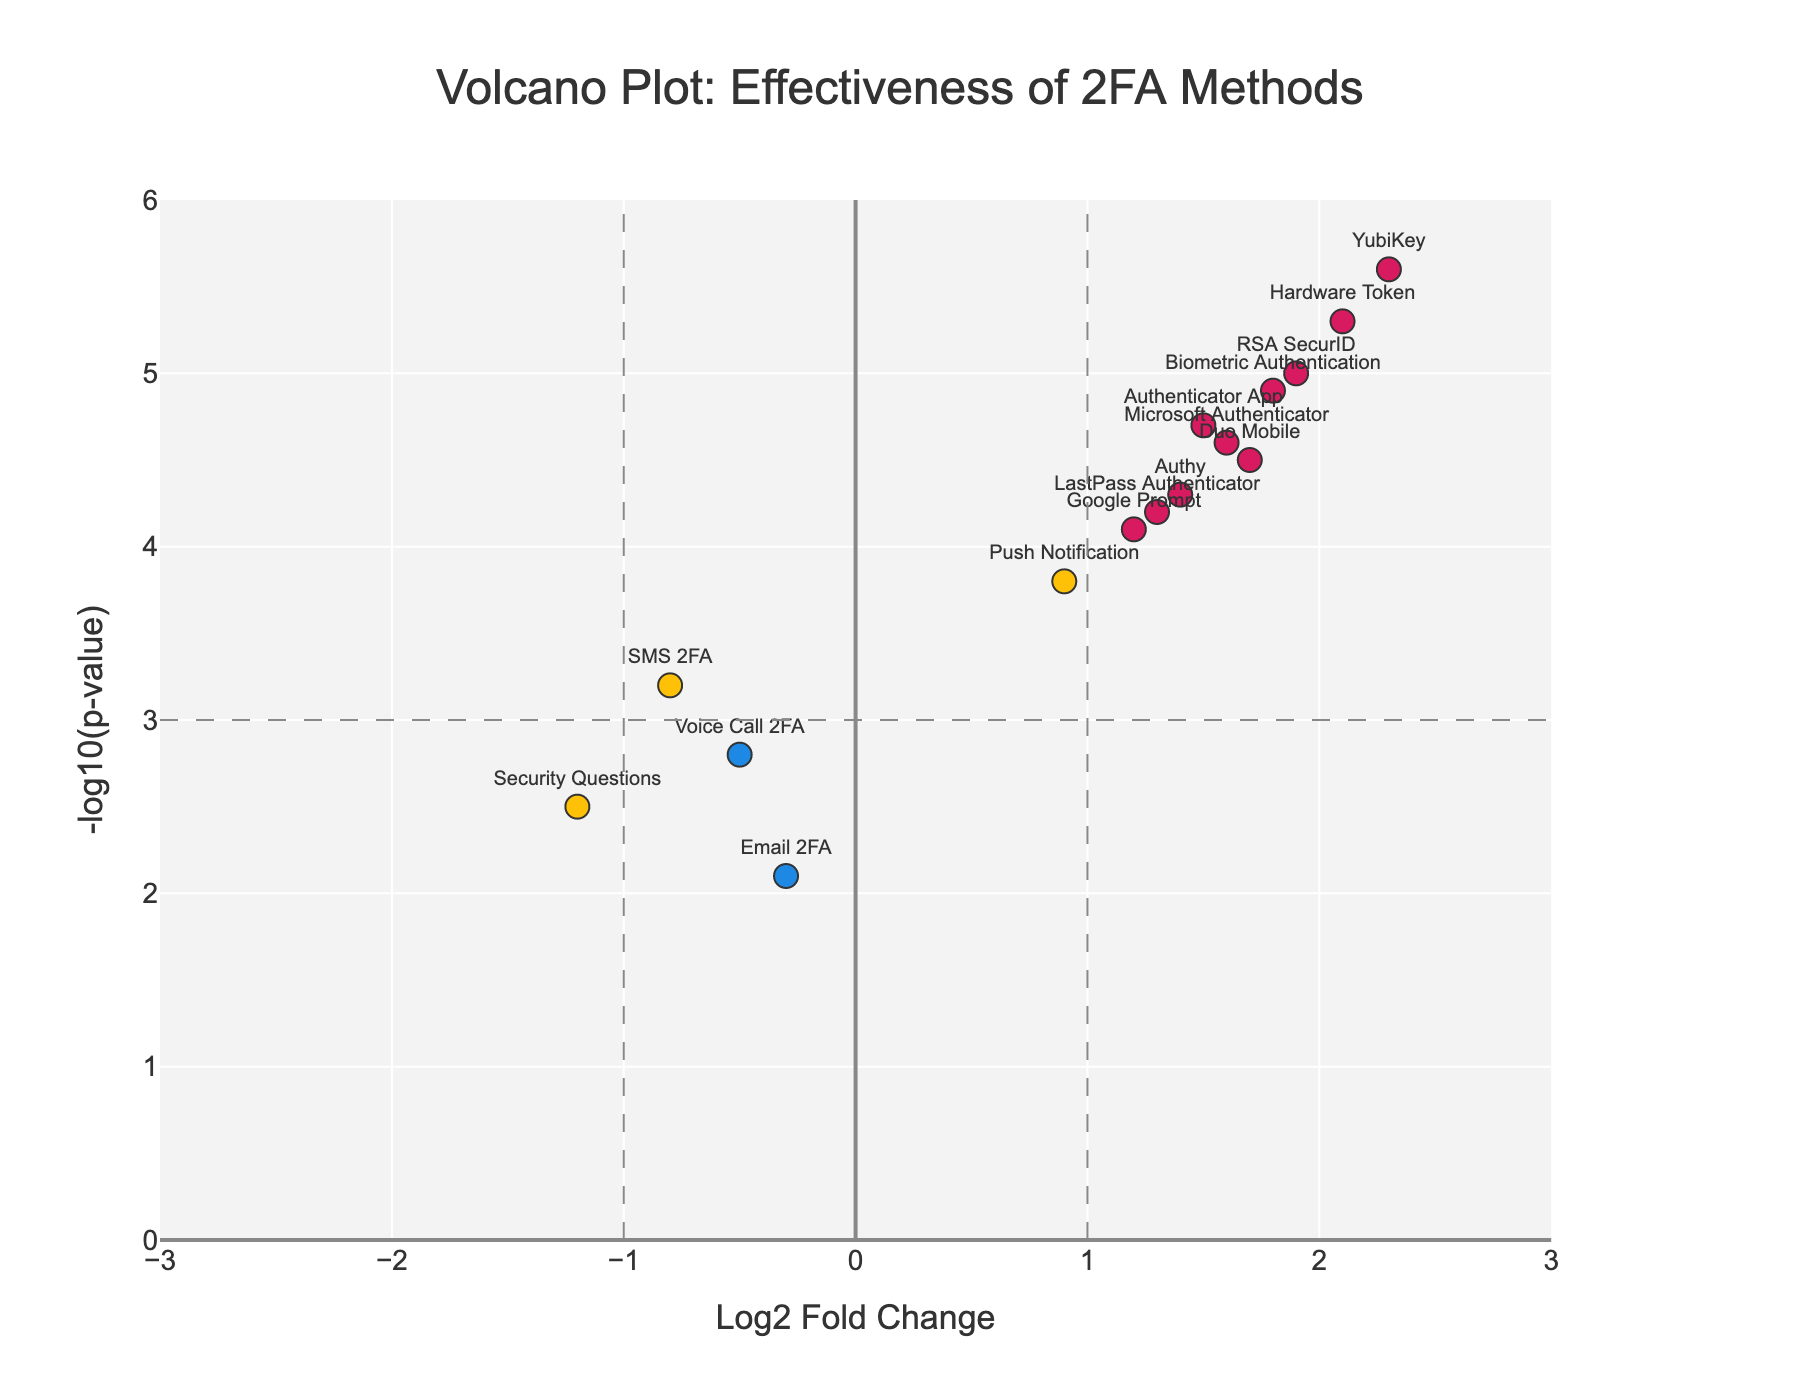What's the title of the figure? The title of the figure is placed at the top of the plot, usually in a larger font size and bold text.
Answer: "Volcano Plot: Effectiveness of 2FA Methods" How many methods have a log2 fold change greater than 1? To determine how many methods have a log2 fold change greater than 1, count all the data points to the right of the vertical dashed line at x = 1.
Answer: 7 Which method has the greatest effectiveness in preventing unauthorized access? The method with the highest effectiveness is identified by the highest log2 fold change and significantly high -log10(p-value). Look for the data point on the far right and highest Y-value.
Answer: YubiKey What is the -log10(p-value) for Authenticator App? Find the location of 'Authenticator App' on the plot and read the Y-axis value corresponding to it. It's shown by the position of the data point vertically.
Answer: 4.7 Which methods are considered significant and effective based on the standard significance thresholds shown? Methods that are colored differently (often in a distinct color) and located in the top-right section above the dashed lines for x = 1 and y = 3. Check which points fall within this criteria.
Answer: Authenticator App, Hardware Token, YubiKey, Biometric Authentication, Duo Mobile, RSA SecurID, Microsoft Authenticator How does the effectiveness of Push Notification compare to SMS 2FA? Compare the positions of Push Notification and SMS 2FA on the plot with respect to Log2FoldChange and -log10(p-value) values.
Answer: Push Notification is more effective as it has a positive log2 fold change and a higher -log10(p-value) compared to SMS 2FA Which method shows the least effectiveness, and what are its Log2FoldChange and -log10(p-value) values? Identify the data point farthest to the left (most negative log2 fold change). The corresponding method and its values are then looked up.
Answer: Security Questions, -1.2, 2.5 Which methods are represented by color indicating significant and both positive and negative log2 fold changes? Identify methods that appear in the unique color for significant values in both positive and negative log2 fold changes, above the p-value threshold line.
Answer: Positive: Authenticator App, Hardware Token, YubiKey, Biometric Authentication, Duo Mobile, RSA SecurID, Microsoft Authenticator. Negative: None What is the average log2 fold change of all methods with -log10(p-value) greater than 4? First, identify all methods with -log10(p-value) > 4, then sum their log2 fold changes and divide by the number of such methods.
Answer: (1.5 + 2.1 + 1.8 + 1.7 + 1.9 + 1.6) / 6 = 1.77 